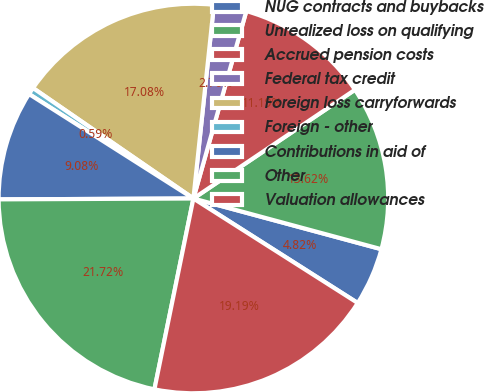Convert chart. <chart><loc_0><loc_0><loc_500><loc_500><pie_chart><fcel>NUG contracts and buybacks<fcel>Unrealized loss on qualifying<fcel>Accrued pension costs<fcel>Federal tax credit<fcel>Foreign loss carryforwards<fcel>Foreign - other<fcel>Contributions in aid of<fcel>Other<fcel>Valuation allowances<nl><fcel>4.82%<fcel>13.62%<fcel>11.19%<fcel>2.7%<fcel>17.08%<fcel>0.59%<fcel>9.08%<fcel>21.72%<fcel>19.19%<nl></chart> 